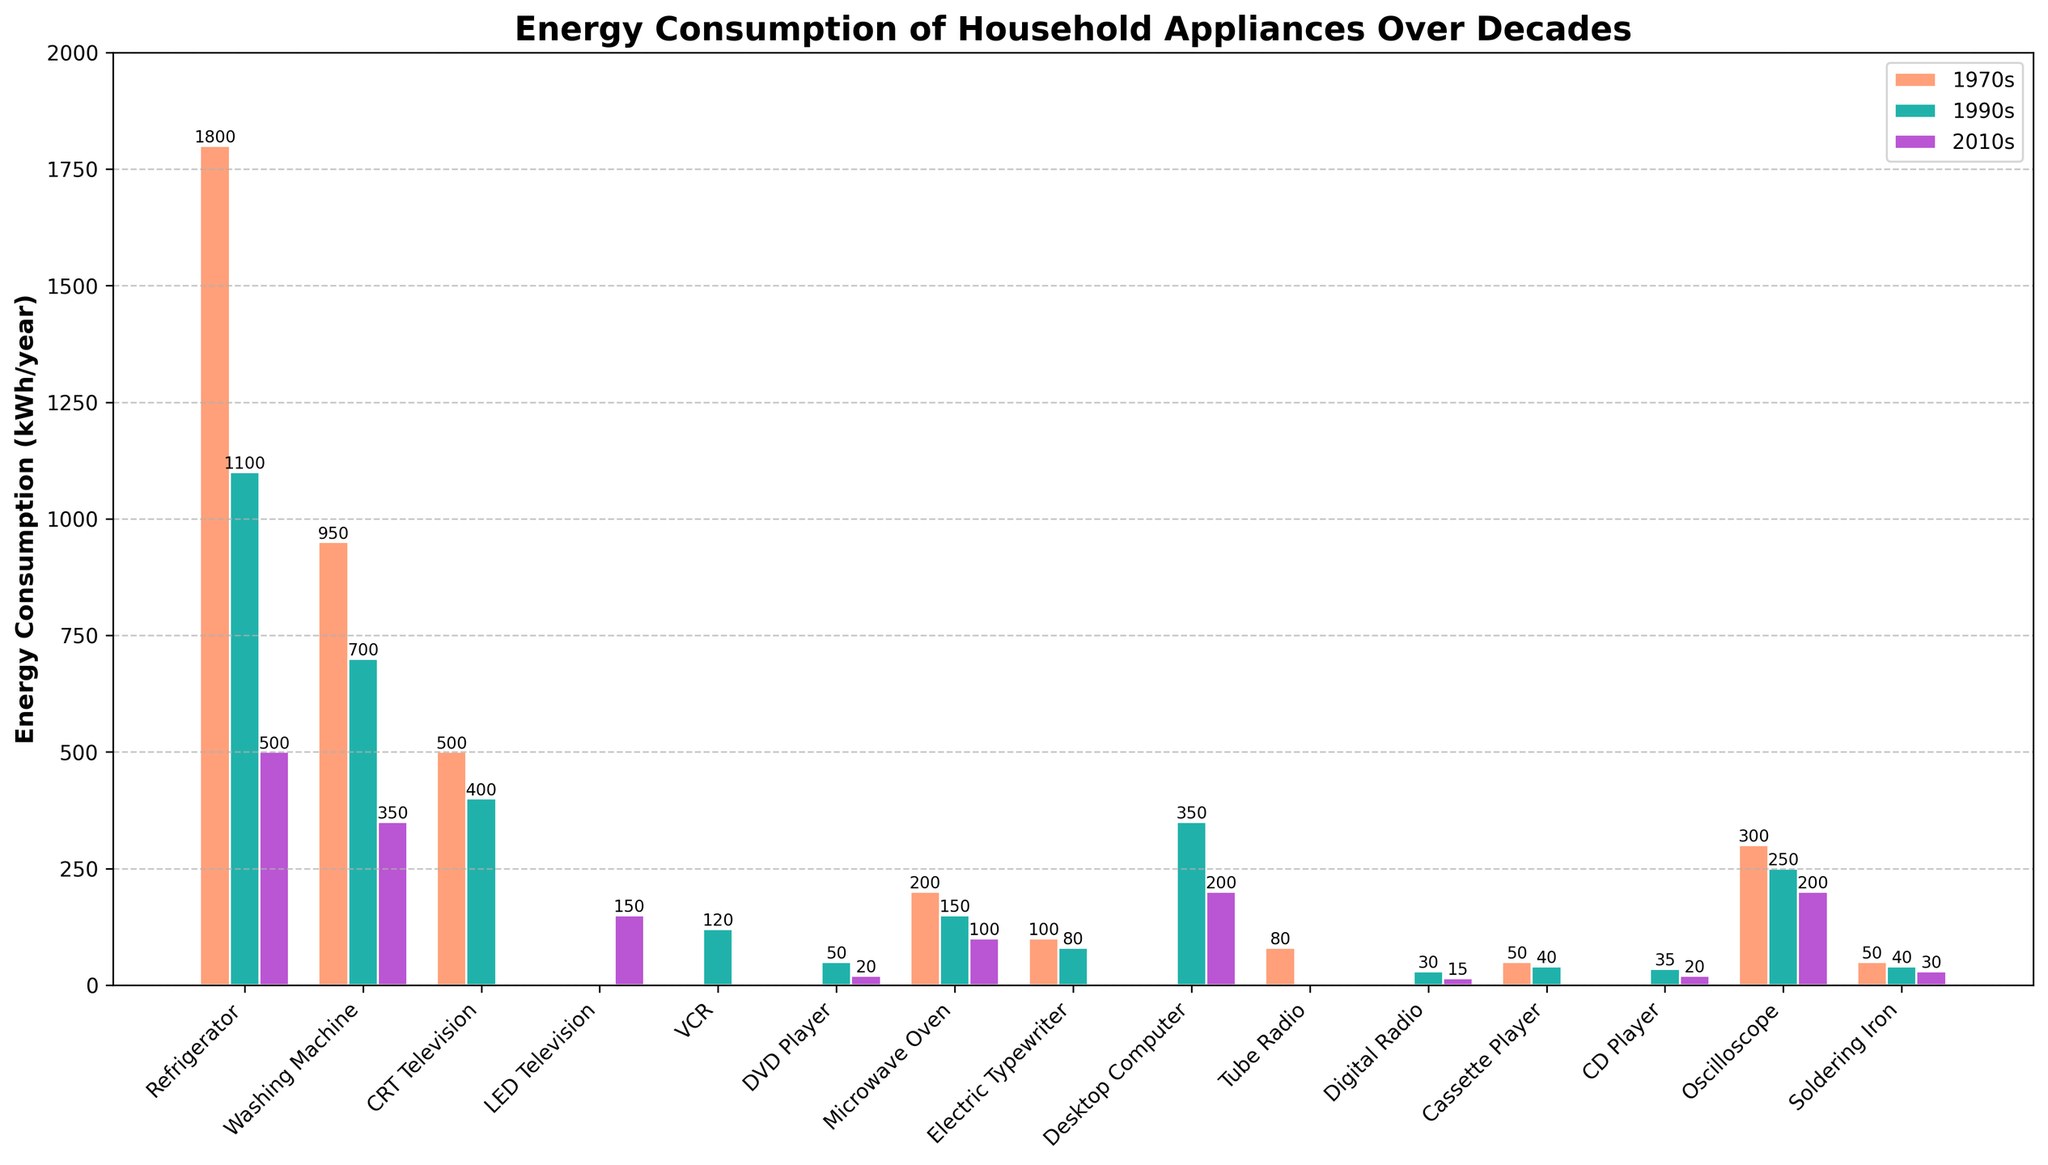what is the energy consumption reduction of a refrigerator from the 1970s to the 2010s? The refrigerator consumed 1800 kWh/year in the 1970s and 500 kWh/year in the 2010s. The reduction is 1800 - 500 = 1300 kWh/year.
Answer: 1300 kWh/year which decade saw the highest energy consumption for CRT televisions? By looking at the bar heights for CRT televisions, the 1970s bar is the highest at 500 kWh/year.
Answer: 1970s what is the difference in energy consumption between an electric typewriter and a desktop computer in the 1990s? The electric typewriter consumed 80 kWh/year, and the desktop computer consumed 350 kWh/year in the 1990s. The difference is 350 - 80 = 270 kWh/year.
Answer: 270 kWh/year how much more energy did a washing machine consume in the 1990s compared to the 2010s? The washing machine consumed 700 kWh/year in the 1990s and 350 kWh/year in the 2010s. The additional consumption is 700 - 350 = 350 kWh/year.
Answer: 350 kWh/year what decade had the least energy consumption for microwaves, and what was the amount? Comparing the bar heights for the microwave oven across decades, the 2010s has the shortest height, showing 100 kWh/year.
Answer: 2010s, 100 kWh/year which appliance showed the greatest decrease in energy consumption from the 1970s to the 2010s? By comparing the differences between the 1970s and 2010s for each appliance, the refrigerator shows the greatest decrease (1800 to 500, a reduction of 1300 kWh/year).
Answer: Refrigerator how much energy, in total, did a soldering iron consume over the three decades? The energy consumption of a soldering iron is 50 kWh/year in the 1970s, 40 kWh/year in the 1990s, and 30 kWh/year in the 2010s. Summing these gives 50 + 40 + 30 = 120 kWh/year.
Answer: 120 kWh/year which appliances are not present in the energy consumption data for the 1970s? Referring to the missing bars in the 1970s category, appliances not present are LED Television, VCR, DVD Player, Desktop Computer, Digital Radio, and CD Player.
Answer: LED Television, VCR, DVD Player, Desktop Computer, Digital Radio, CD Player what is the average energy consumption of an oscilloscope over the three decades? The oscilloscope consumed 300 kWh/year in the 1970s, 250 kWh/year in the 1990s, and 200 kWh/year in the 2010s. The average is (300 + 250 + 200) / 3 = 250 kWh/year.
Answer: 250 kWh/year 